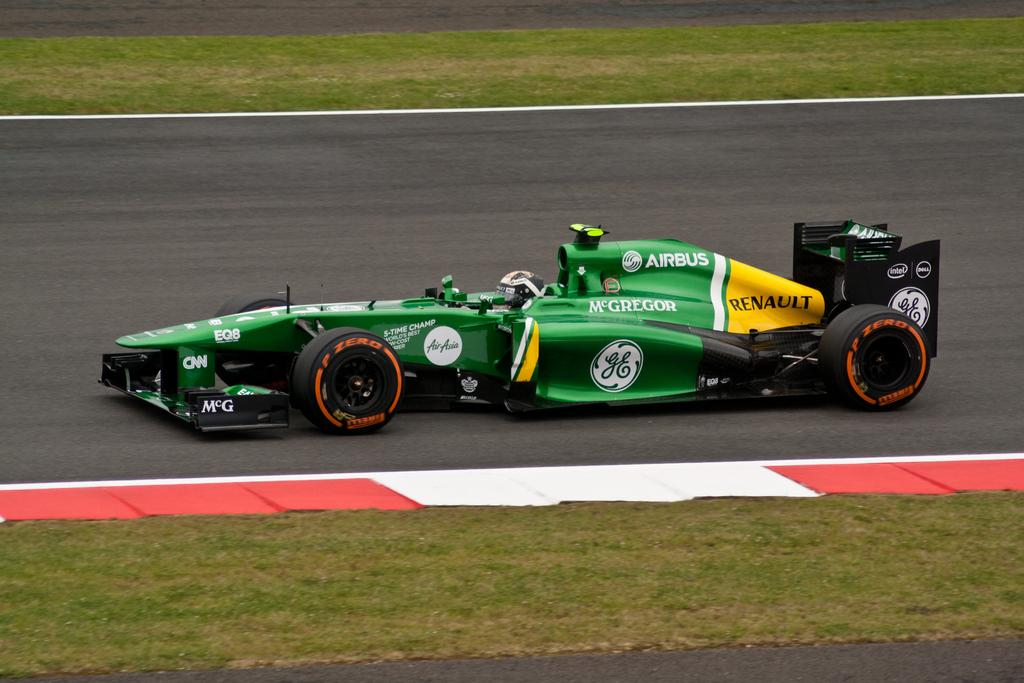What type of vehicle is in the image? There is a sports car in the image. Where is the sports car located? The sports car is on the road. What type of vegetation is visible at the top and bottom of the image? Grass is visible at the top and bottom of the image. What type of watch is the governor wearing in the image? There is no watch or governor present in the image; it features a sports car on the road with grass visible at the top and bottom. 